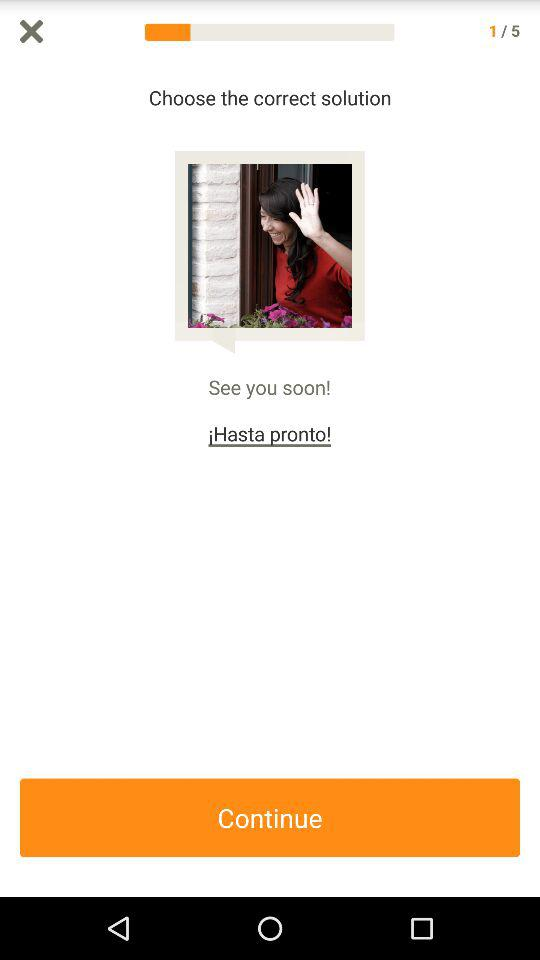Currently, we are on which question number? Currently, you are on question number one. 